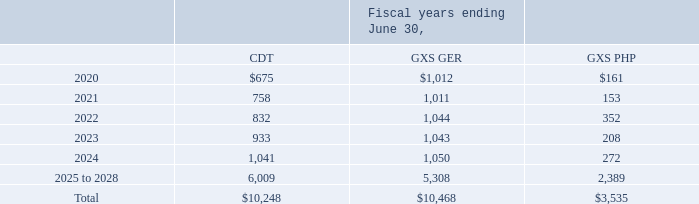Pensions
As of June 30, 2019, our total unfunded pension plan obligations were $77.5 million, of which $2.3 million is payable within the next twelve months. We expect to be able to make the long-term and short-term payments related to these obligations in the normal course of operations.
Our anticipated payments under our most significant plans for the fiscal years indicated below are as follows:
For a detailed discussion on pensions, see note 11 "Pension Plans and Other Post Retirement Benefits" to our Consolidated Financial Statements.
What does the table show? Anticipated payments under our most significant plans for the fiscal years. Where is a detailed discussion on pensions found? Note 11 "pension plans and other post retirement benefits" to our consolidated financial statements. What is the Total CDT for all years?
Answer scale should be: thousand. 10,248. What is the CDT of Fiscal year 2020 expressed as a percentage of Total CDT?
Answer scale should be: percent. 675/10,248
Answer: 6.59. What is the total anticipated payments for all plans till fiscal year 2028?
Answer scale should be: thousand. 10,248+10,468+3,535
Answer: 24251. What is the average annual payment for GXS PHP for fiscal year 2020 to 2024?
Answer scale should be: thousand. (161+153+352+208+272)/5
Answer: 229.2. 